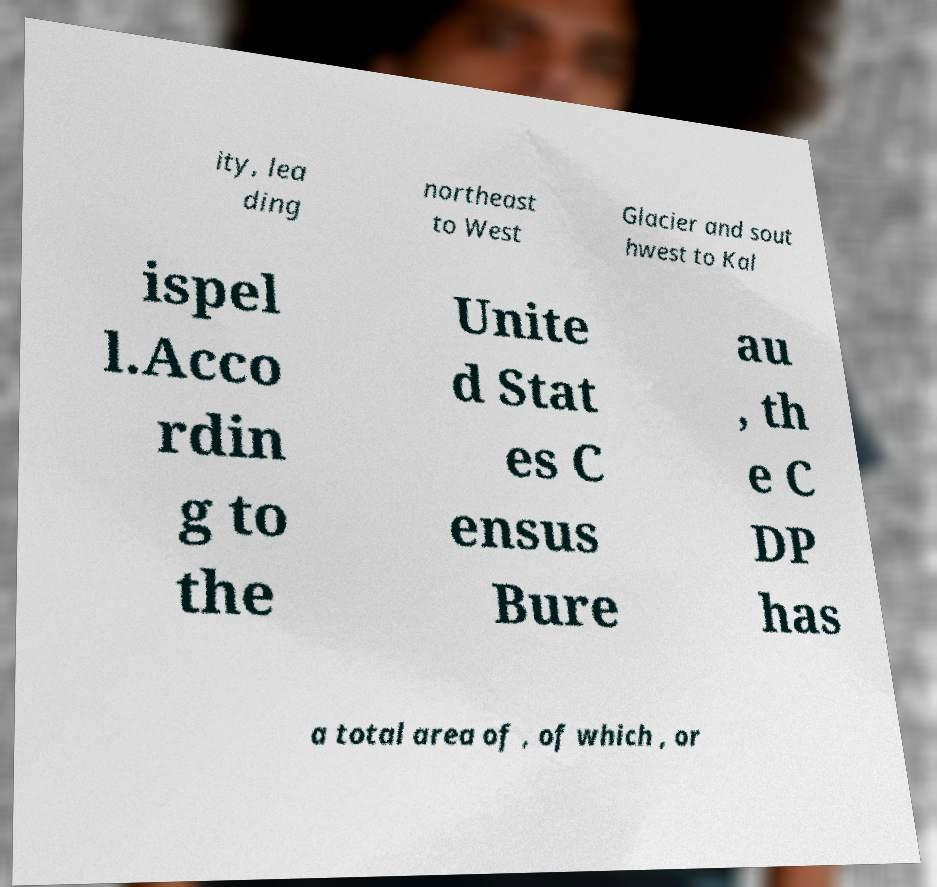Can you read and provide the text displayed in the image?This photo seems to have some interesting text. Can you extract and type it out for me? ity, lea ding northeast to West Glacier and sout hwest to Kal ispel l.Acco rdin g to the Unite d Stat es C ensus Bure au , th e C DP has a total area of , of which , or 